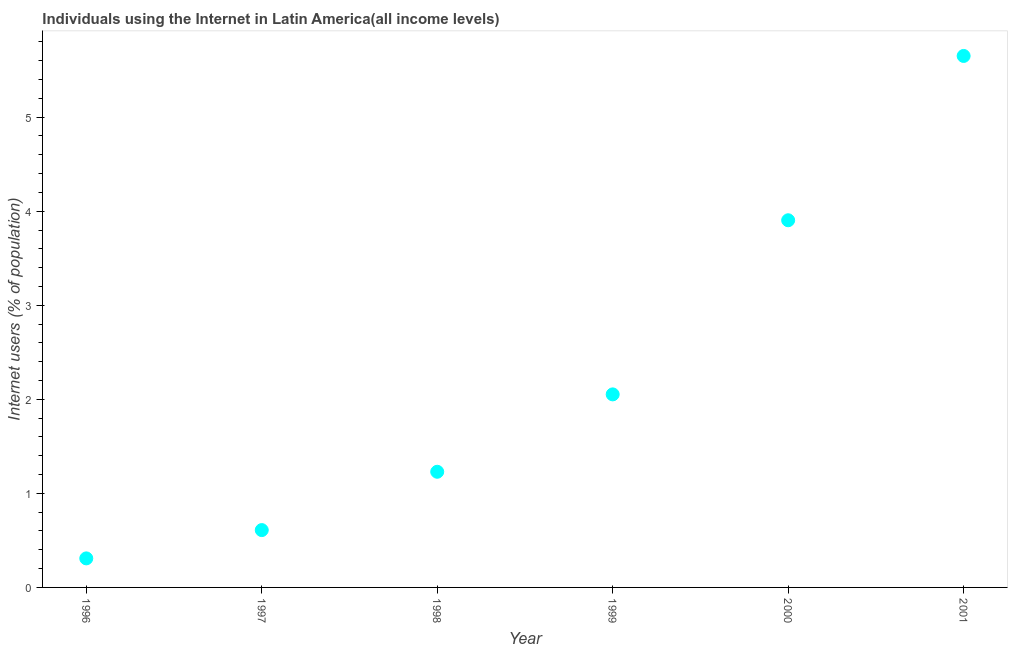What is the number of internet users in 1999?
Your answer should be very brief. 2.05. Across all years, what is the maximum number of internet users?
Keep it short and to the point. 5.65. Across all years, what is the minimum number of internet users?
Your answer should be compact. 0.31. In which year was the number of internet users maximum?
Your answer should be compact. 2001. In which year was the number of internet users minimum?
Offer a terse response. 1996. What is the sum of the number of internet users?
Provide a succinct answer. 13.75. What is the difference between the number of internet users in 2000 and 2001?
Your answer should be compact. -1.75. What is the average number of internet users per year?
Offer a terse response. 2.29. What is the median number of internet users?
Your answer should be compact. 1.64. Do a majority of the years between 2001 and 1999 (inclusive) have number of internet users greater than 4.6 %?
Your answer should be very brief. No. What is the ratio of the number of internet users in 1999 to that in 2000?
Provide a short and direct response. 0.53. Is the number of internet users in 1996 less than that in 1997?
Your response must be concise. Yes. What is the difference between the highest and the second highest number of internet users?
Ensure brevity in your answer.  1.75. What is the difference between the highest and the lowest number of internet users?
Offer a terse response. 5.34. Does the number of internet users monotonically increase over the years?
Your answer should be very brief. Yes. How many dotlines are there?
Give a very brief answer. 1. What is the difference between two consecutive major ticks on the Y-axis?
Your response must be concise. 1. Does the graph contain grids?
Offer a very short reply. No. What is the title of the graph?
Offer a very short reply. Individuals using the Internet in Latin America(all income levels). What is the label or title of the X-axis?
Your answer should be compact. Year. What is the label or title of the Y-axis?
Provide a succinct answer. Internet users (% of population). What is the Internet users (% of population) in 1996?
Provide a succinct answer. 0.31. What is the Internet users (% of population) in 1997?
Make the answer very short. 0.61. What is the Internet users (% of population) in 1998?
Keep it short and to the point. 1.23. What is the Internet users (% of population) in 1999?
Your answer should be very brief. 2.05. What is the Internet users (% of population) in 2000?
Offer a terse response. 3.9. What is the Internet users (% of population) in 2001?
Give a very brief answer. 5.65. What is the difference between the Internet users (% of population) in 1996 and 1997?
Keep it short and to the point. -0.3. What is the difference between the Internet users (% of population) in 1996 and 1998?
Provide a succinct answer. -0.92. What is the difference between the Internet users (% of population) in 1996 and 1999?
Make the answer very short. -1.74. What is the difference between the Internet users (% of population) in 1996 and 2000?
Keep it short and to the point. -3.59. What is the difference between the Internet users (% of population) in 1996 and 2001?
Give a very brief answer. -5.34. What is the difference between the Internet users (% of population) in 1997 and 1998?
Your answer should be very brief. -0.62. What is the difference between the Internet users (% of population) in 1997 and 1999?
Your answer should be compact. -1.44. What is the difference between the Internet users (% of population) in 1997 and 2000?
Give a very brief answer. -3.29. What is the difference between the Internet users (% of population) in 1997 and 2001?
Make the answer very short. -5.04. What is the difference between the Internet users (% of population) in 1998 and 1999?
Your answer should be compact. -0.82. What is the difference between the Internet users (% of population) in 1998 and 2000?
Provide a short and direct response. -2.67. What is the difference between the Internet users (% of population) in 1998 and 2001?
Provide a succinct answer. -4.42. What is the difference between the Internet users (% of population) in 1999 and 2000?
Provide a succinct answer. -1.85. What is the difference between the Internet users (% of population) in 1999 and 2001?
Your answer should be very brief. -3.6. What is the difference between the Internet users (% of population) in 2000 and 2001?
Offer a terse response. -1.75. What is the ratio of the Internet users (% of population) in 1996 to that in 1997?
Offer a terse response. 0.51. What is the ratio of the Internet users (% of population) in 1996 to that in 1998?
Provide a succinct answer. 0.25. What is the ratio of the Internet users (% of population) in 1996 to that in 2000?
Your answer should be compact. 0.08. What is the ratio of the Internet users (% of population) in 1996 to that in 2001?
Give a very brief answer. 0.06. What is the ratio of the Internet users (% of population) in 1997 to that in 1998?
Provide a succinct answer. 0.5. What is the ratio of the Internet users (% of population) in 1997 to that in 1999?
Your response must be concise. 0.3. What is the ratio of the Internet users (% of population) in 1997 to that in 2000?
Provide a succinct answer. 0.16. What is the ratio of the Internet users (% of population) in 1997 to that in 2001?
Keep it short and to the point. 0.11. What is the ratio of the Internet users (% of population) in 1998 to that in 1999?
Your answer should be compact. 0.6. What is the ratio of the Internet users (% of population) in 1998 to that in 2000?
Offer a terse response. 0.32. What is the ratio of the Internet users (% of population) in 1998 to that in 2001?
Give a very brief answer. 0.22. What is the ratio of the Internet users (% of population) in 1999 to that in 2000?
Offer a very short reply. 0.53. What is the ratio of the Internet users (% of population) in 1999 to that in 2001?
Ensure brevity in your answer.  0.36. What is the ratio of the Internet users (% of population) in 2000 to that in 2001?
Provide a succinct answer. 0.69. 